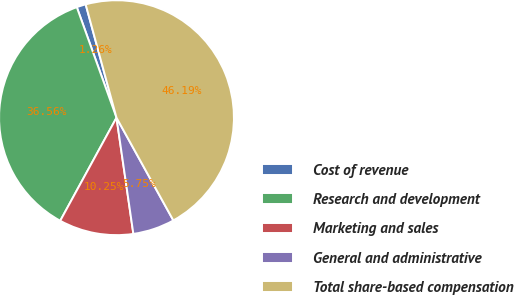Convert chart. <chart><loc_0><loc_0><loc_500><loc_500><pie_chart><fcel>Cost of revenue<fcel>Research and development<fcel>Marketing and sales<fcel>General and administrative<fcel>Total share-based compensation<nl><fcel>1.26%<fcel>36.56%<fcel>10.25%<fcel>5.75%<fcel>46.19%<nl></chart> 